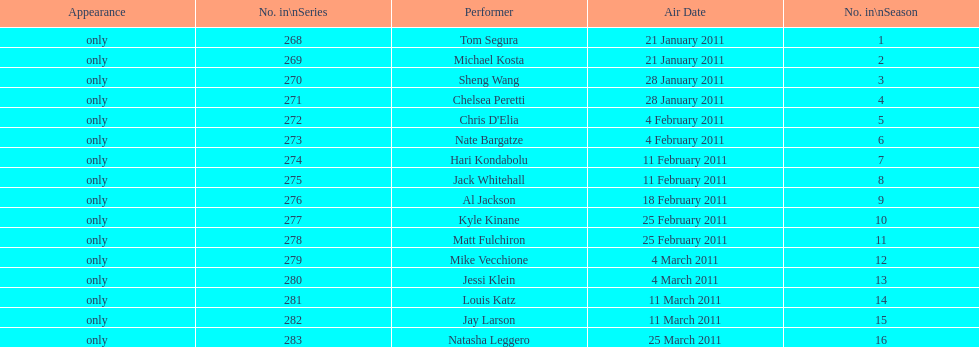Did al jackson air before or after kyle kinane? Before. 